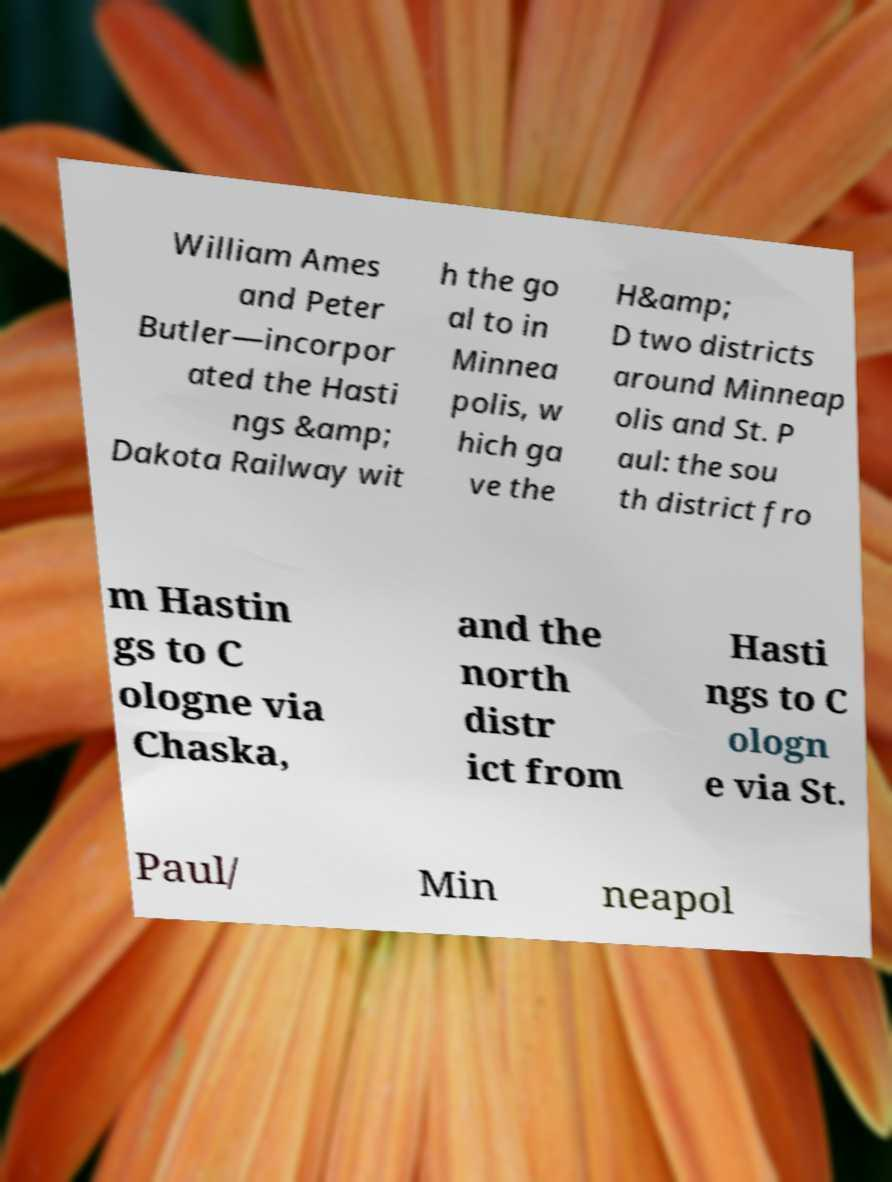Could you assist in decoding the text presented in this image and type it out clearly? William Ames and Peter Butler—incorpor ated the Hasti ngs &amp; Dakota Railway wit h the go al to in Minnea polis, w hich ga ve the H&amp; D two districts around Minneap olis and St. P aul: the sou th district fro m Hastin gs to C ologne via Chaska, and the north distr ict from Hasti ngs to C ologn e via St. Paul/ Min neapol 